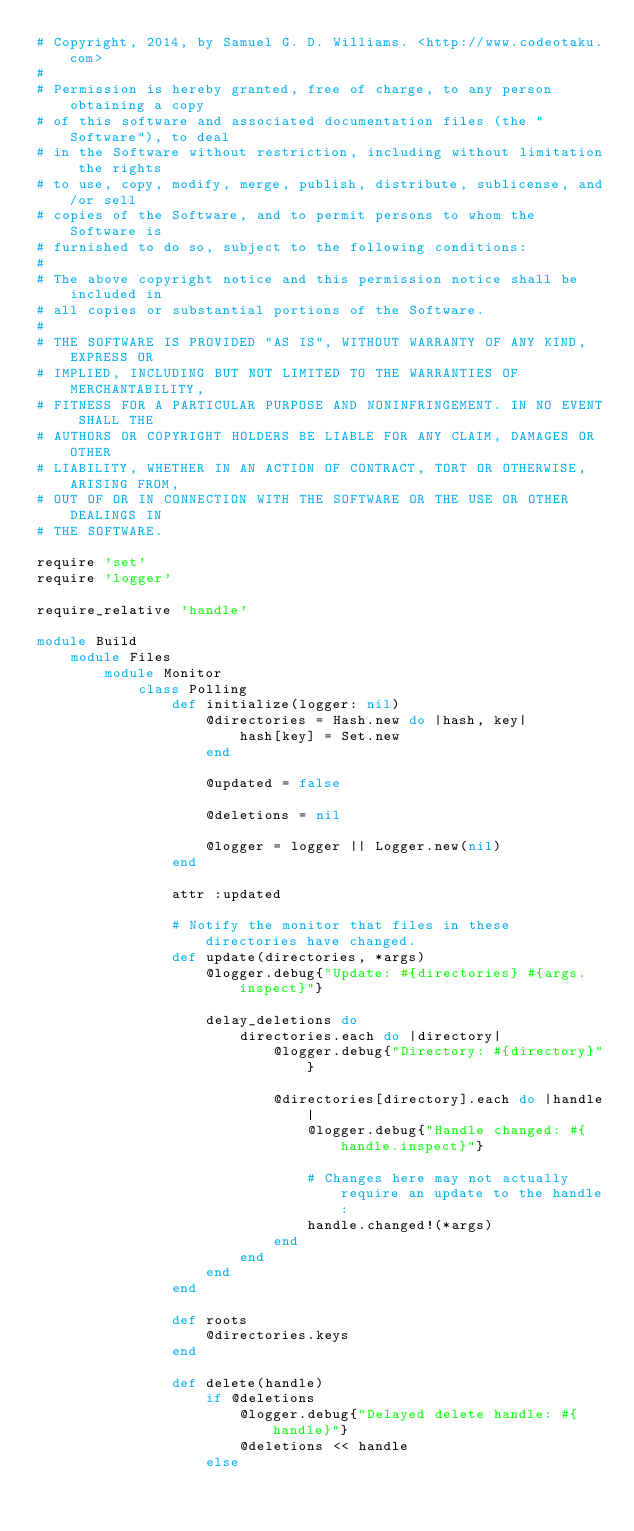Convert code to text. <code><loc_0><loc_0><loc_500><loc_500><_Ruby_># Copyright, 2014, by Samuel G. D. Williams. <http://www.codeotaku.com>
# 
# Permission is hereby granted, free of charge, to any person obtaining a copy
# of this software and associated documentation files (the "Software"), to deal
# in the Software without restriction, including without limitation the rights
# to use, copy, modify, merge, publish, distribute, sublicense, and/or sell
# copies of the Software, and to permit persons to whom the Software is
# furnished to do so, subject to the following conditions:
# 
# The above copyright notice and this permission notice shall be included in
# all copies or substantial portions of the Software.
# 
# THE SOFTWARE IS PROVIDED "AS IS", WITHOUT WARRANTY OF ANY KIND, EXPRESS OR
# IMPLIED, INCLUDING BUT NOT LIMITED TO THE WARRANTIES OF MERCHANTABILITY,
# FITNESS FOR A PARTICULAR PURPOSE AND NONINFRINGEMENT. IN NO EVENT SHALL THE
# AUTHORS OR COPYRIGHT HOLDERS BE LIABLE FOR ANY CLAIM, DAMAGES OR OTHER
# LIABILITY, WHETHER IN AN ACTION OF CONTRACT, TORT OR OTHERWISE, ARISING FROM,
# OUT OF OR IN CONNECTION WITH THE SOFTWARE OR THE USE OR OTHER DEALINGS IN
# THE SOFTWARE.

require 'set'
require 'logger'

require_relative 'handle'

module Build
	module Files
		module Monitor
			class Polling
				def initialize(logger: nil)
					@directories = Hash.new do |hash, key|
						hash[key] = Set.new
					end
					
					@updated = false
					
					@deletions = nil
					
					@logger = logger || Logger.new(nil)
				end
				
				attr :updated
				
				# Notify the monitor that files in these directories have changed.
				def update(directories, *args)
					@logger.debug{"Update: #{directories} #{args.inspect}"}
					
					delay_deletions do
						directories.each do |directory|
							@logger.debug{"Directory: #{directory}"}
							
							@directories[directory].each do |handle|
								@logger.debug{"Handle changed: #{handle.inspect}"}
								
								# Changes here may not actually require an update to the handle:
								handle.changed!(*args)
							end
						end
					end
				end
				
				def roots
					@directories.keys
				end
				
				def delete(handle)
					if @deletions
						@logger.debug{"Delayed delete handle: #{handle}"}
						@deletions << handle
					else</code> 